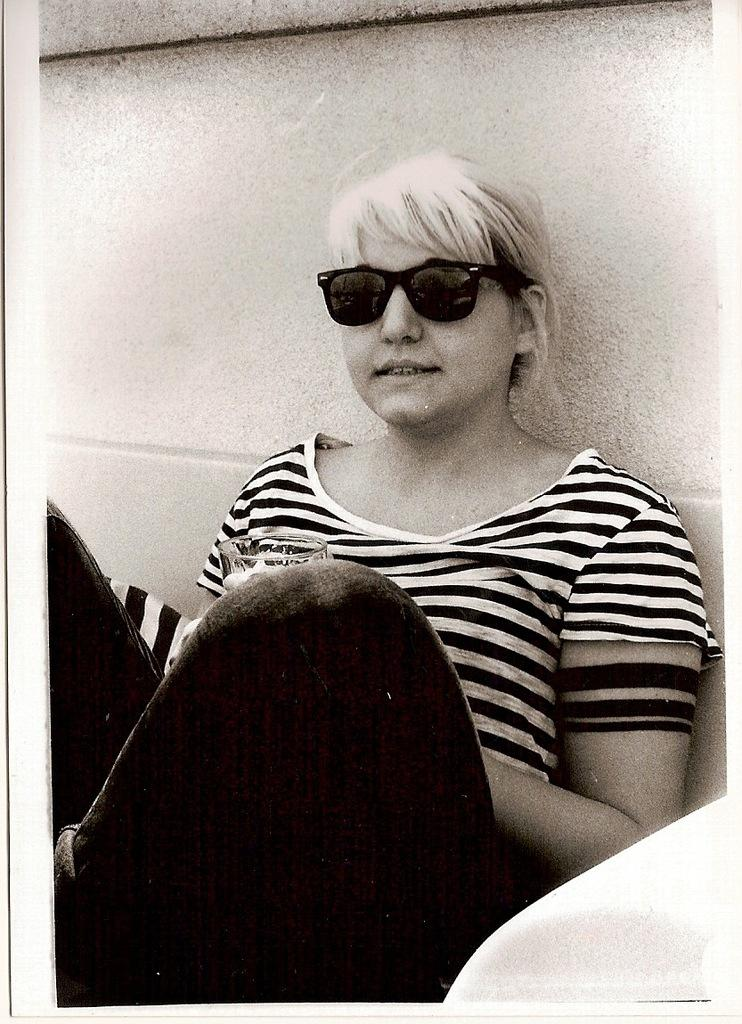Who is present in the image? There is a woman in the image. What is the woman holding in her hand? The woman is holding a glass in her hand. Where is the woman sitting in relation to the wall? The woman is sitting near a wall. What type of transport is the woman using to travel in the image? There is no transport visible in the image; the woman is sitting near a wall. Can you describe the blade that the woman is holding in the image? There is no blade present in the image; the woman is holding a glass. 